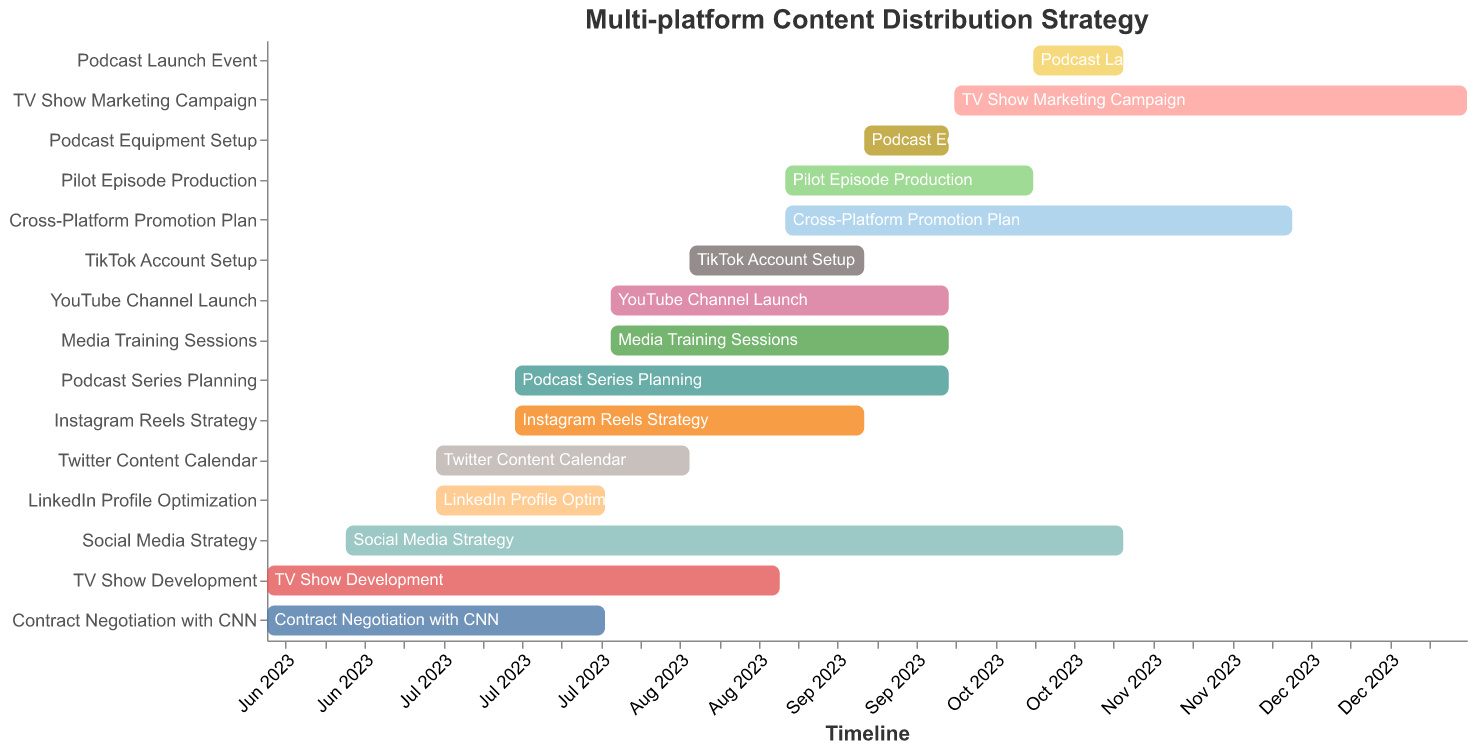When does the "TV Show Development" task start and end? The "TV Show Development" task spans from June 1, 2023, to August 31, 2023. This information is directly visible within the bar chart's timeline.
Answer: June 1, 2023, to August 31, 2023 Which task has the longest duration? To determine the longest task, compare the duration of each task. "Social Media Strategy" spans from June 15, 2023, to October 31, 2023, which is approximately 4.5 months, making it the longest task.
Answer: Social Media Strategy How many tasks overlap in the month of September 2023? By reviewing the chart, the tasks overlapping in September are "Podcast Series Planning," "Social Media Strategy," "Pilot Episode Production," "Podcast Equipment Setup," "Instagram Reels Strategy," "YouTube Channel Launch," "Cross-Platform Promotion Plan," "TikTok Account Setup," and "Media Training Sessions". Counting these tasks gives us 9 overlaps.
Answer: 9 What is the gap between the end of "Contract Negotiation with CNN" and the start of "Pilot Episode Production"? "Contract Negotiation with CNN" ends on July 31, 2023, and "Pilot Episode Production" starts on September 1, 2023. The gap between these dates is from August 1 to August 31, 2023, which is 1 month.
Answer: 1 month Which tasks involve planning or strategy, and how long do they last? The tasks involving planning or strategy are "Podcast Series Planning," "Social Media Strategy," "Twitter Content Calendar," "Instagram Reels Strategy," and "Cross-Platform Promotion Plan." Their durations are: Podcast Series Planning: 2.5 months, Social Media Strategy: 4.5 months, Twitter Content Calendar: 1.5 months, Instagram Reels Strategy: 2 months, Cross-Platform Promotion Plan: 3 months.
Answer: Various durations; mostly between 1.5 to 4.5 months Which task ends the latest and when does it end? The task with the latest end date is "TV Show Marketing Campaign," which ends on December 31, 2023. This is clearly indicated at the far right of the figure's timeline.
Answer: TV Show Marketing Campaign, December 31, 2023 What tasks start after September 1, 2023? Tasks starting after September 1, 2023, are "Podcast Equipment Setup," "Cross-Platform Promotion Plan," and "Podcast Launch Event."
Answer: Podcast Equipment Setup, Cross-Platform Promotion Plan, Podcast Launch Event Which tasks are related to podcasts and how do their durations vary? Tasks related to podcasts are "Podcast Series Planning," "Podcast Equipment Setup," and "Podcast Launch Event." Their durations are: Podcast Series Planning - 2.5 months, Podcast Equipment Setup - 15 days, Podcast Launch Event - 15 days.
Answer: Durations vary from 15 days to 2.5 months During which months is "Media Training Sessions" active? "Media Training Sessions" is active from August 1, 2023, to September 30, 2023, as deduced from its start and end dates. It spans both August and September.
Answer: August and September 